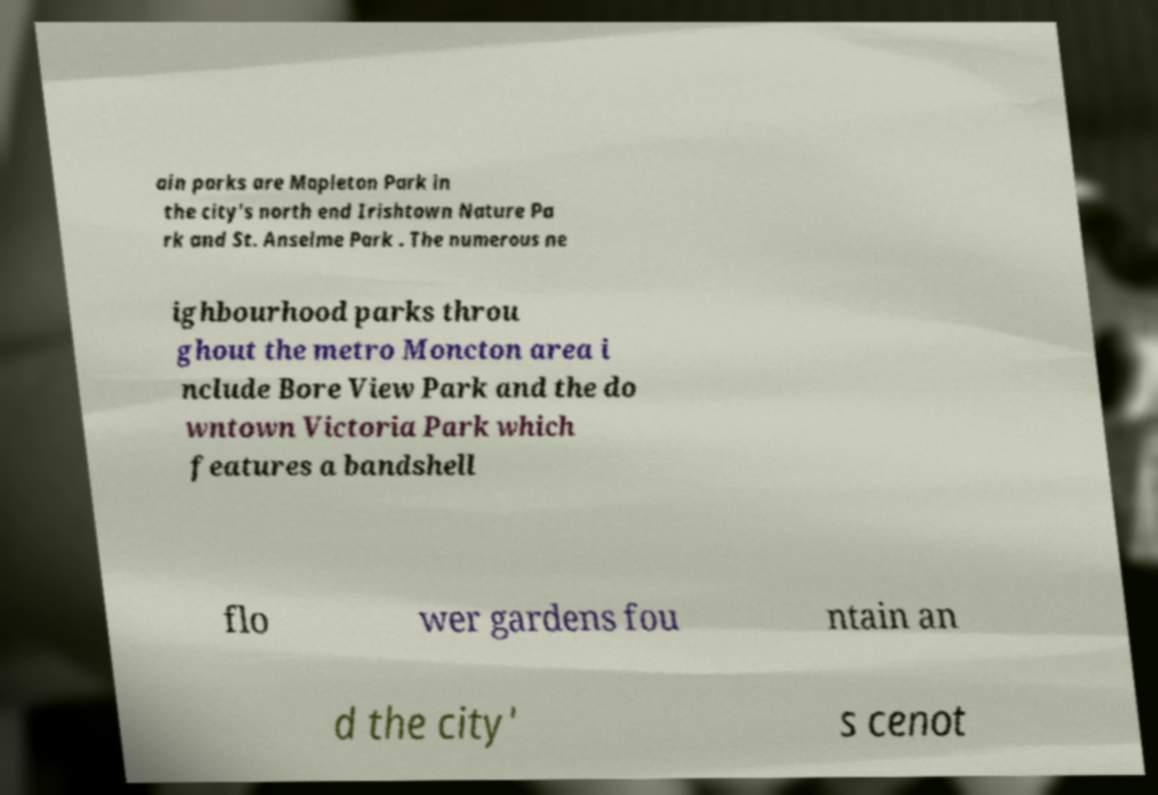For documentation purposes, I need the text within this image transcribed. Could you provide that? ain parks are Mapleton Park in the city's north end Irishtown Nature Pa rk and St. Anselme Park . The numerous ne ighbourhood parks throu ghout the metro Moncton area i nclude Bore View Park and the do wntown Victoria Park which features a bandshell flo wer gardens fou ntain an d the city' s cenot 